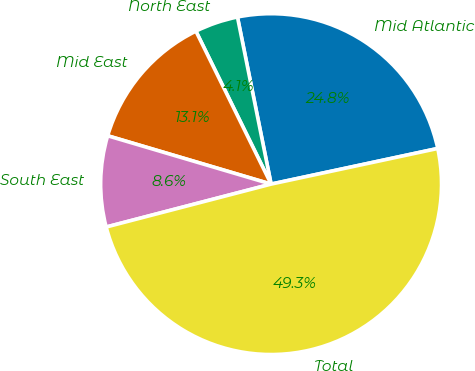<chart> <loc_0><loc_0><loc_500><loc_500><pie_chart><fcel>Mid Atlantic<fcel>North East<fcel>Mid East<fcel>South East<fcel>Total<nl><fcel>24.81%<fcel>4.11%<fcel>13.15%<fcel>8.63%<fcel>49.3%<nl></chart> 